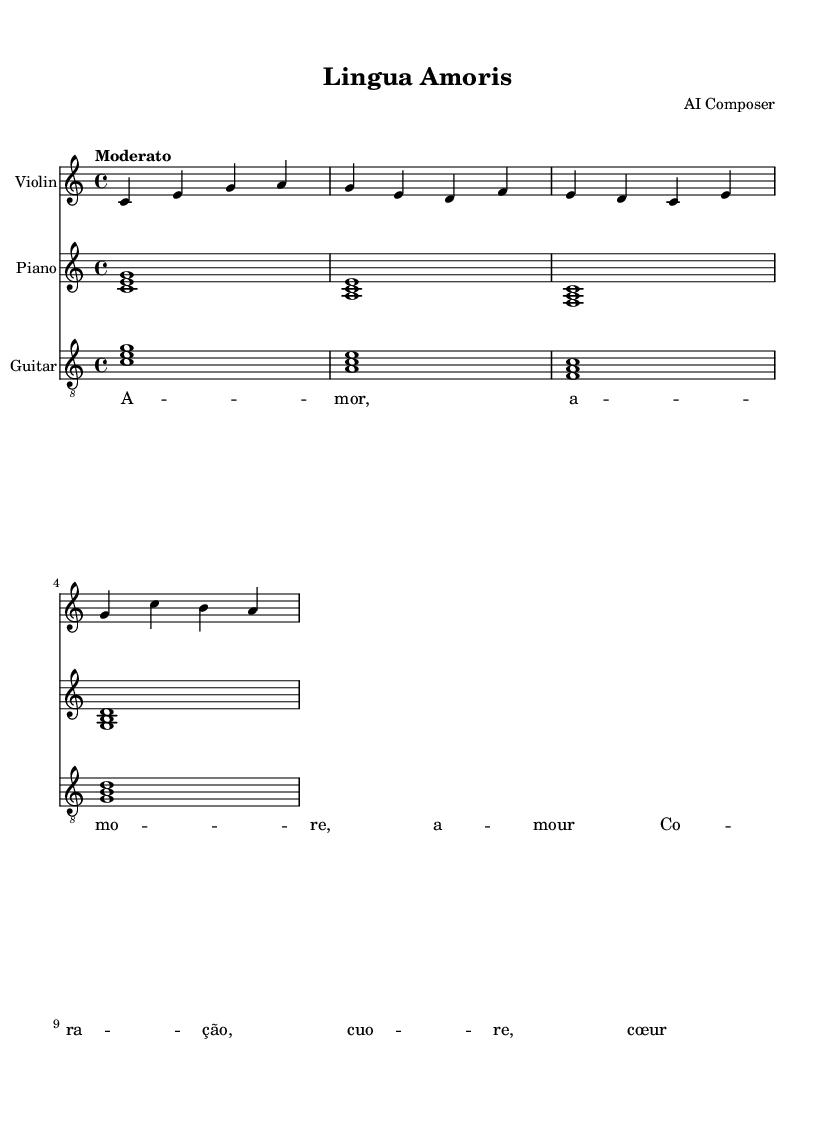What is the key signature of this music? The key signature is C major, which has no sharps or flats.
Answer: C major What is the time signature of the piece? The time signature is indicated in the beginning of the music as 4/4, which means there are four beats in each measure.
Answer: 4/4 What is the tempo marking of the piece? The tempo marking is "Moderato", which suggests a moderate speed for the performance of this music.
Answer: Moderato How many measures are in the violin part? By counting the measures in the violin part, there are four distinct measures present.
Answer: 4 What type of accompaniment is used for the piano and guitar? Both the piano and guitar parts consist of chordal accompaniment, playing harmonies along with the melody.
Answer: Chordal What are the lyrics of the piece, mentioning the languages? The lyrics are presented in various Romance languages, notably Italian and Portuguese, with words like "amore" and "coração".
Answer: amore, coração What instruments are part of the score? The score includes three instruments: violin, piano, and guitar.
Answer: Violin, piano, guitar 